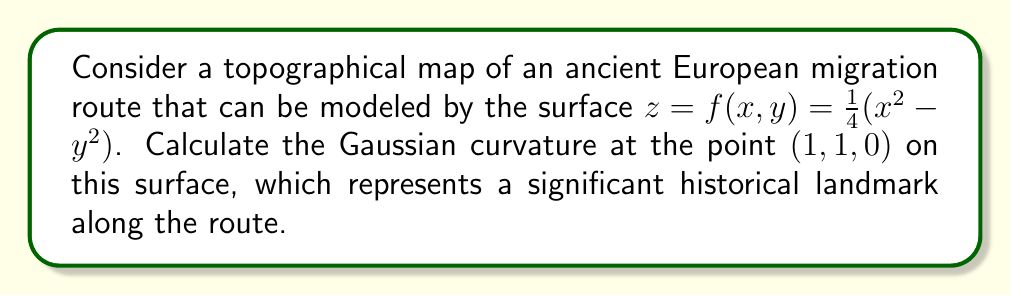Could you help me with this problem? To calculate the Gaussian curvature, we'll follow these steps:

1) The Gaussian curvature K is given by:
   $$K = \frac{f_{xx}f_{yy} - f_{xy}^2}{(1 + f_x^2 + f_y^2)^2}$$

2) Calculate the partial derivatives:
   $$f_x = \frac{1}{2}x$$
   $$f_y = -\frac{1}{2}y$$
   $$f_{xx} = \frac{1}{2}$$
   $$f_{yy} = -\frac{1}{2}$$
   $$f_{xy} = 0$$

3) Evaluate these at the point (1, 1, 0):
   $$f_x = \frac{1}{2}$$
   $$f_y = -\frac{1}{2}$$
   $$f_{xx} = \frac{1}{2}$$
   $$f_{yy} = -\frac{1}{2}$$
   $$f_{xy} = 0$$

4) Substitute into the formula:
   $$K = \frac{(\frac{1}{2})(-\frac{1}{2}) - 0^2}{(1 + (\frac{1}{2})^2 + (-\frac{1}{2})^2)^2}$$

5) Simplify:
   $$K = \frac{-\frac{1}{4}}{(1 + \frac{1}{4} + \frac{1}{4})^2} = \frac{-\frac{1}{4}}{(\frac{3}{2})^2} = -\frac{1}{9}$$

Thus, the Gaussian curvature at the point (1, 1, 0) is $-\frac{1}{9}$.
Answer: $-\frac{1}{9}$ 